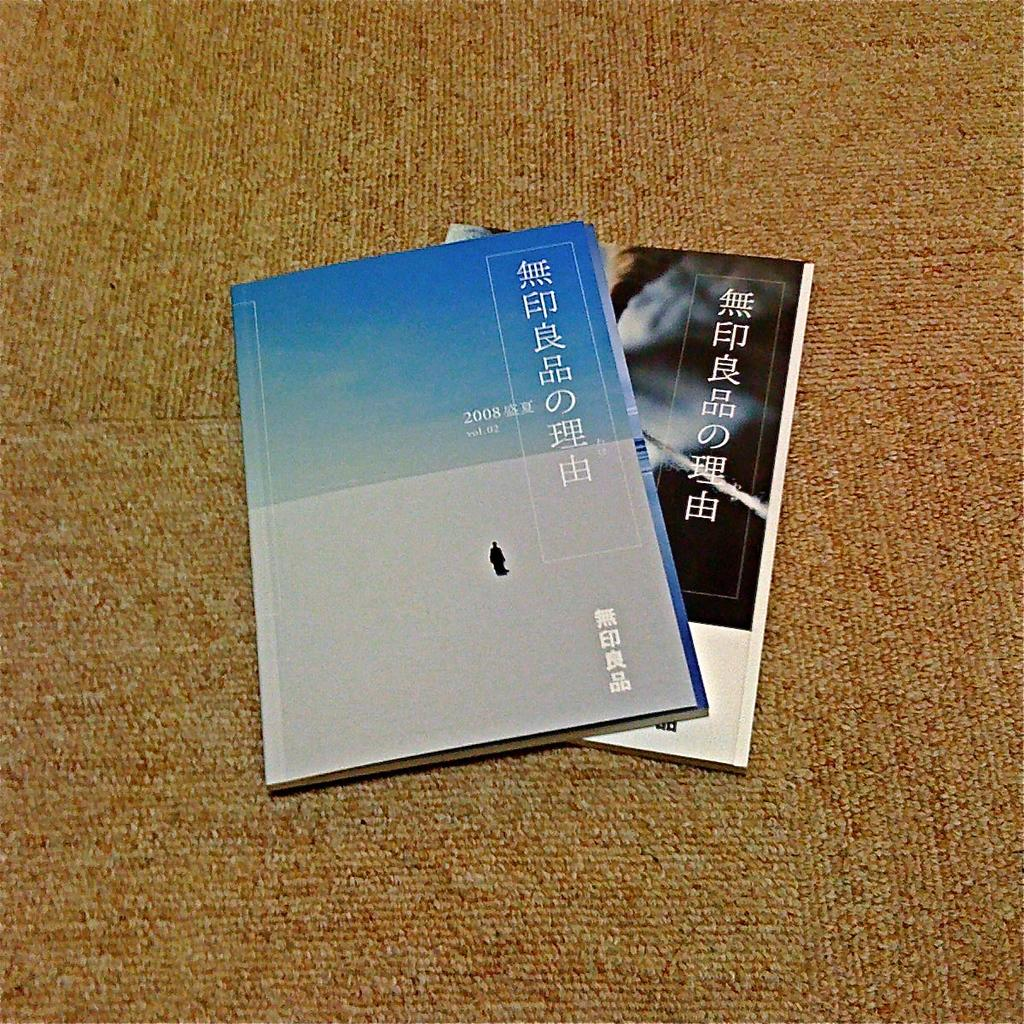What objects are present in the image? There are books in the image. Where are the books located? The books are on a carpet. What can be seen on the books? There is text on the books. What type of ear is visible in the image? There is no ear present in the image; it features books on a carpet. 